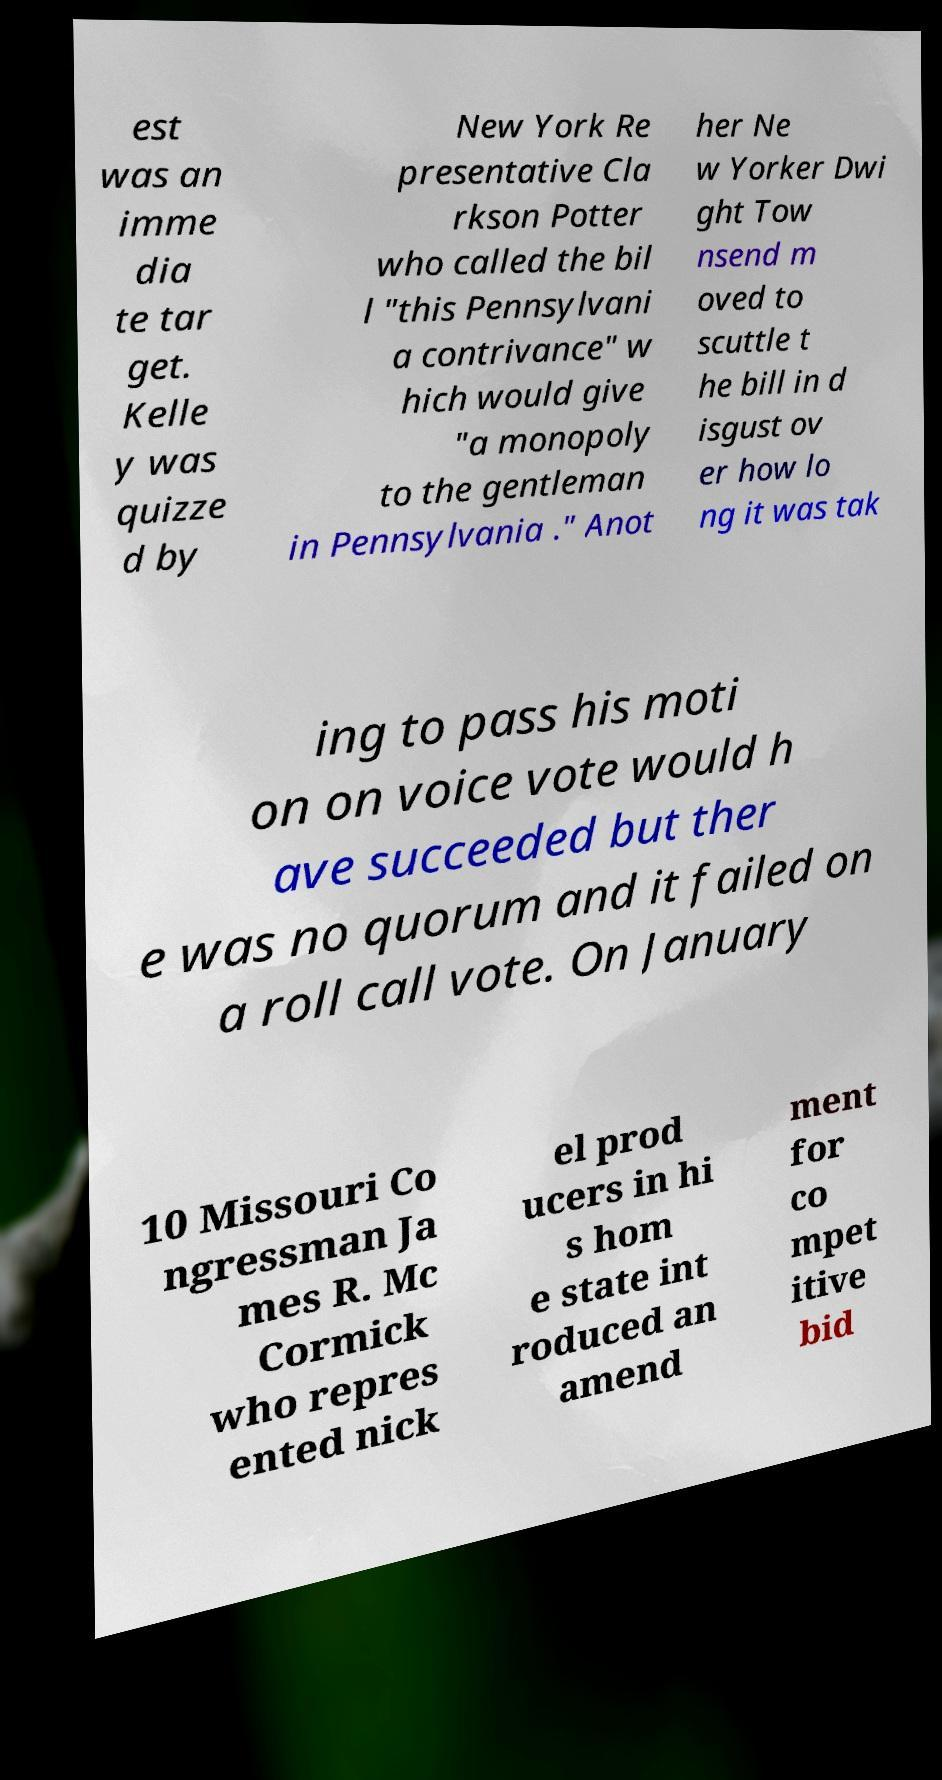There's text embedded in this image that I need extracted. Can you transcribe it verbatim? est was an imme dia te tar get. Kelle y was quizze d by New York Re presentative Cla rkson Potter who called the bil l "this Pennsylvani a contrivance" w hich would give "a monopoly to the gentleman in Pennsylvania ." Anot her Ne w Yorker Dwi ght Tow nsend m oved to scuttle t he bill in d isgust ov er how lo ng it was tak ing to pass his moti on on voice vote would h ave succeeded but ther e was no quorum and it failed on a roll call vote. On January 10 Missouri Co ngressman Ja mes R. Mc Cormick who repres ented nick el prod ucers in hi s hom e state int roduced an amend ment for co mpet itive bid 